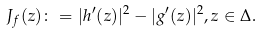Convert formula to latex. <formula><loc_0><loc_0><loc_500><loc_500>J _ { f } ( z ) \colon = | h ^ { \prime } ( z ) | ^ { 2 } - | g ^ { \prime } ( z ) | ^ { 2 } , z \in \Delta .</formula> 